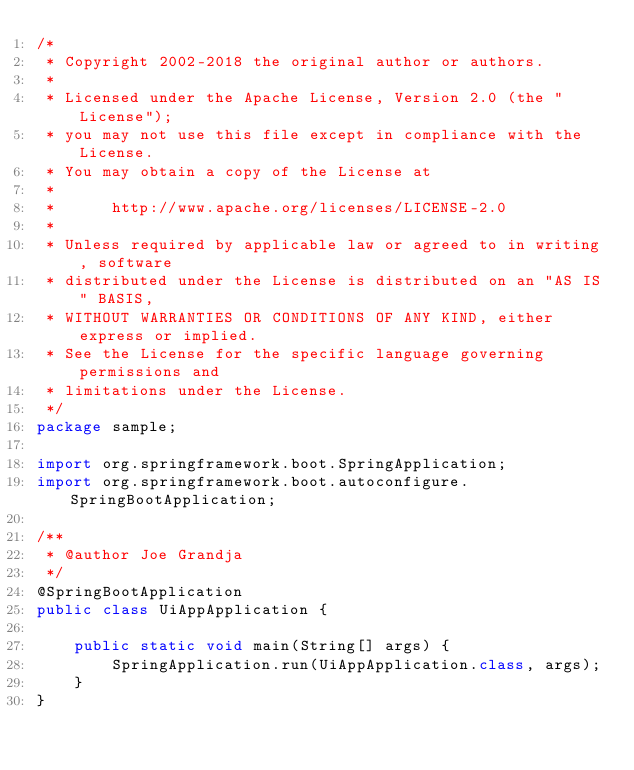Convert code to text. <code><loc_0><loc_0><loc_500><loc_500><_Java_>/*
 * Copyright 2002-2018 the original author or authors.
 *
 * Licensed under the Apache License, Version 2.0 (the "License");
 * you may not use this file except in compliance with the License.
 * You may obtain a copy of the License at
 *
 *      http://www.apache.org/licenses/LICENSE-2.0
 *
 * Unless required by applicable law or agreed to in writing, software
 * distributed under the License is distributed on an "AS IS" BASIS,
 * WITHOUT WARRANTIES OR CONDITIONS OF ANY KIND, either express or implied.
 * See the License for the specific language governing permissions and
 * limitations under the License.
 */
package sample;

import org.springframework.boot.SpringApplication;
import org.springframework.boot.autoconfigure.SpringBootApplication;

/**
 * @author Joe Grandja
 */
@SpringBootApplication
public class UiAppApplication {

	public static void main(String[] args) {
		SpringApplication.run(UiAppApplication.class, args);
	}
}</code> 